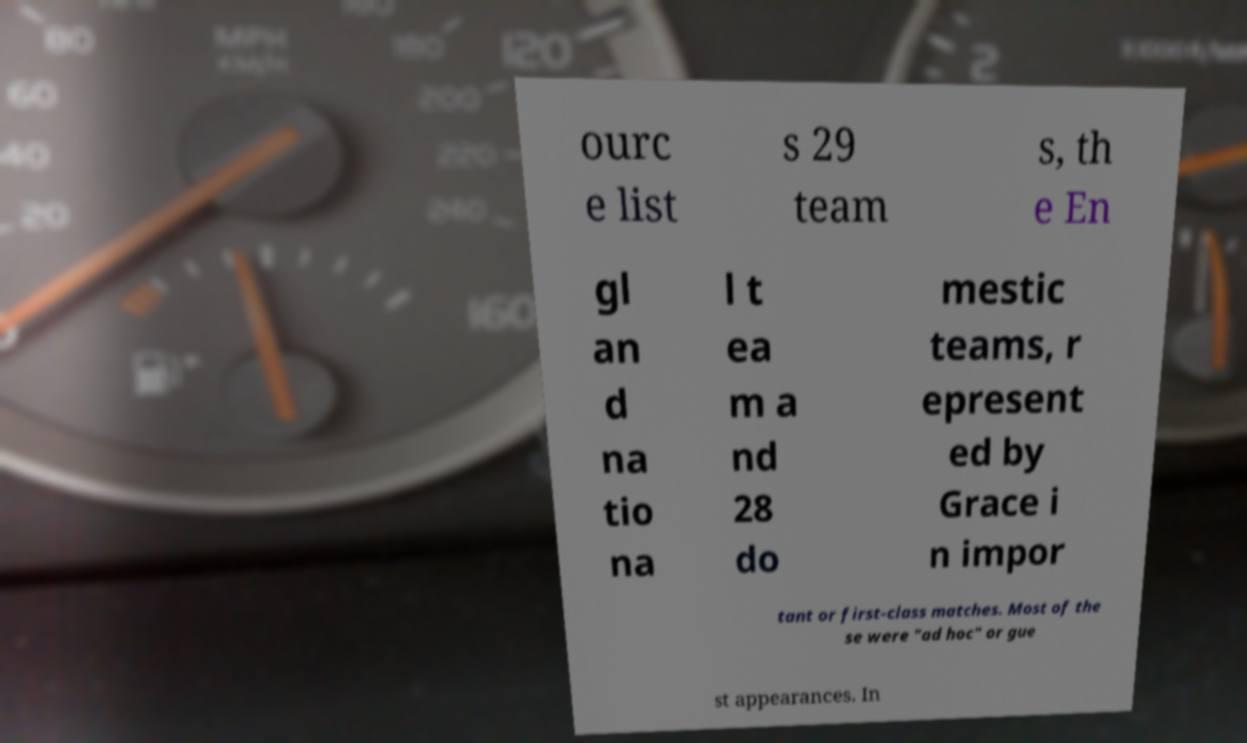There's text embedded in this image that I need extracted. Can you transcribe it verbatim? ourc e list s 29 team s, th e En gl an d na tio na l t ea m a nd 28 do mestic teams, r epresent ed by Grace i n impor tant or first-class matches. Most of the se were "ad hoc" or gue st appearances. In 